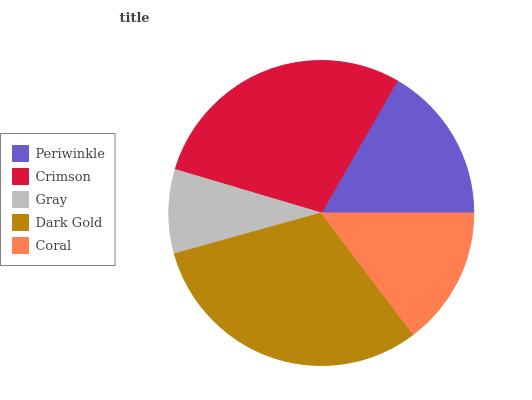Is Gray the minimum?
Answer yes or no. Yes. Is Dark Gold the maximum?
Answer yes or no. Yes. Is Crimson the minimum?
Answer yes or no. No. Is Crimson the maximum?
Answer yes or no. No. Is Crimson greater than Periwinkle?
Answer yes or no. Yes. Is Periwinkle less than Crimson?
Answer yes or no. Yes. Is Periwinkle greater than Crimson?
Answer yes or no. No. Is Crimson less than Periwinkle?
Answer yes or no. No. Is Periwinkle the high median?
Answer yes or no. Yes. Is Periwinkle the low median?
Answer yes or no. Yes. Is Coral the high median?
Answer yes or no. No. Is Gray the low median?
Answer yes or no. No. 